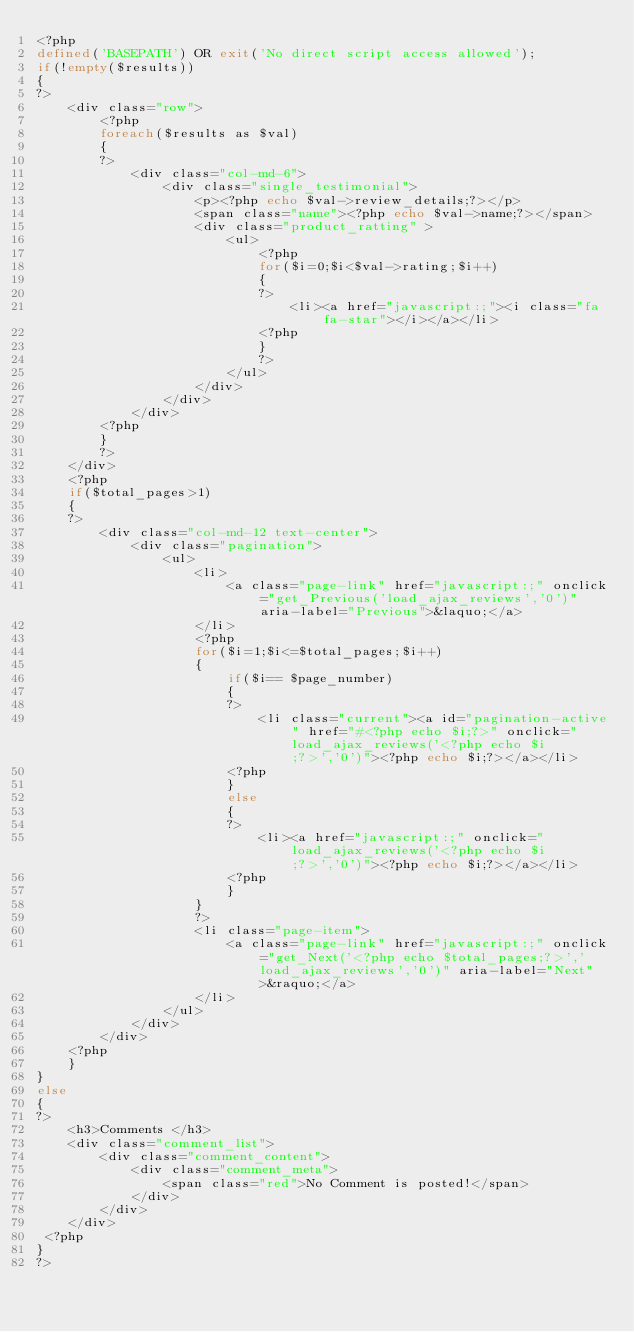Convert code to text. <code><loc_0><loc_0><loc_500><loc_500><_PHP_><?php
defined('BASEPATH') OR exit('No direct script access allowed');
if(!empty($results))
{
?>
	<div class="row">
		<?php
		foreach($results as $val)
		{
		?>
			<div class="col-md-6">
				<div class="single_testimonial">
					<p><?php echo $val->review_details;?></p>
					<span class="name"><?php echo $val->name;?></span>
					<div class="product_ratting" >
						<ul>
							<?php
							for($i=0;$i<$val->rating;$i++)
							{
							?>
								<li><a href="javascript:;"><i class="fa fa-star"></i></a></li>
							<?php
							}
							?>
						</ul>
					</div>
				</div>
			</div>
		<?php
		}
		?>
	</div>
	<?php
	if($total_pages>1)
	{
	?>
		<div class="col-md-12 text-center">
			<div class="pagination">
				<ul>
					<li>
						<a class="page-link" href="javascript:;" onclick="get_Previous('load_ajax_reviews','0')" aria-label="Previous">&laquo;</a>
					</li>
					<?php
					for($i=1;$i<=$total_pages;$i++)
					{
						if($i== $page_number)
						{
						?>
							<li class="current"><a id="pagination-active" href="#<?php echo $i;?>" onclick="load_ajax_reviews('<?php echo $i;?>','0')"><?php echo $i;?></a></li>
						<?php
						}
						else
						{
						?>
							<li><a href="javascript:;" onclick="load_ajax_reviews('<?php echo $i;?>','0')"><?php echo $i;?></a></li>
						<?php
						}
					}
					?>
					<li class="page-item">
						<a class="page-link" href="javascript:;" onclick="get_Next('<?php echo $total_pages;?>','load_ajax_reviews','0')" aria-label="Next">&raquo;</a>
					</li>
				</ul>
			</div>
		</div>
	<?php
	}
}
else
{
?>
	<h3>Comments </h3>
 	<div class="comment_list">
		<div class="comment_content">
			<div class="comment_meta">
 				<span class="red">No Comment is posted!</span>
			</div>
 		</div>
	</div>
 <?php
}
?>
</code> 